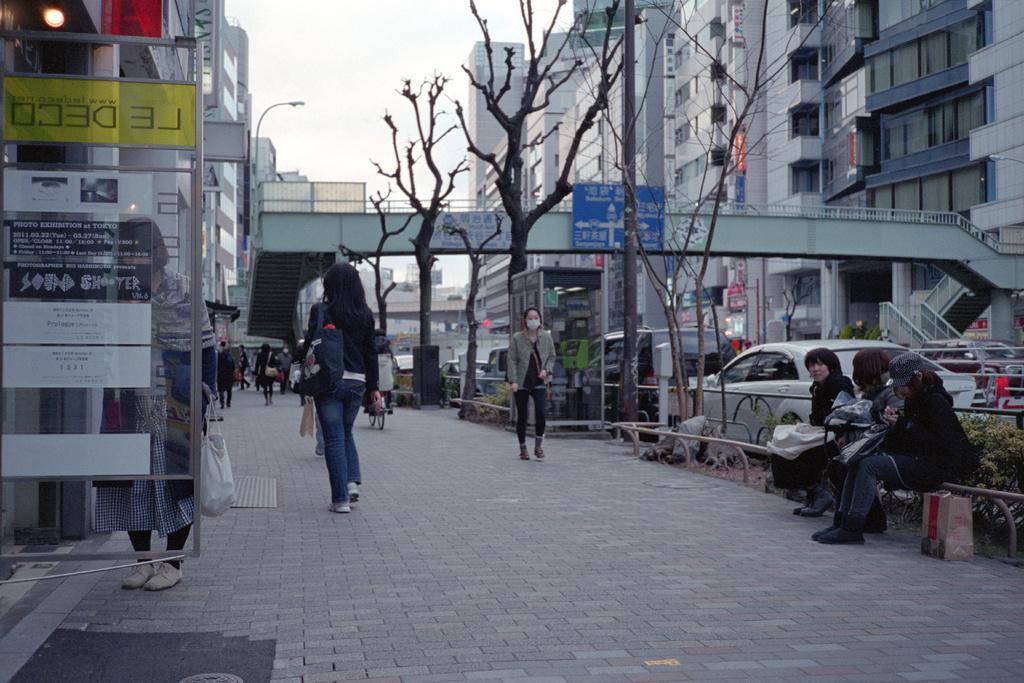How would you summarize this image in a sentence or two? In the image in the center, we can see a few people are walking and few people are sitting. In the background, we can see the sky, clouds, trees, buildings, banners, sign boards, poles, vehicles etc. 